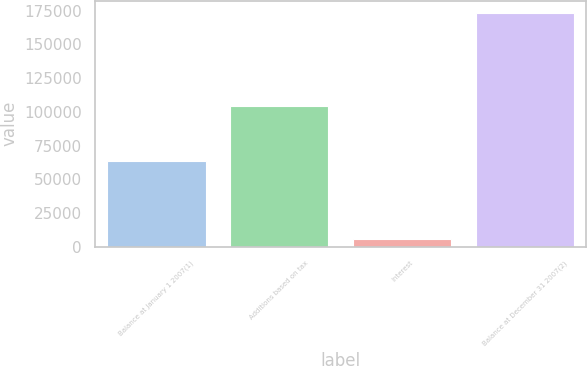Convert chart. <chart><loc_0><loc_0><loc_500><loc_500><bar_chart><fcel>Balance at January 1 2007(1)<fcel>Additions based on tax<fcel>Interest<fcel>Balance at December 31 2007(2)<nl><fcel>63710<fcel>104231<fcel>5652<fcel>173593<nl></chart> 